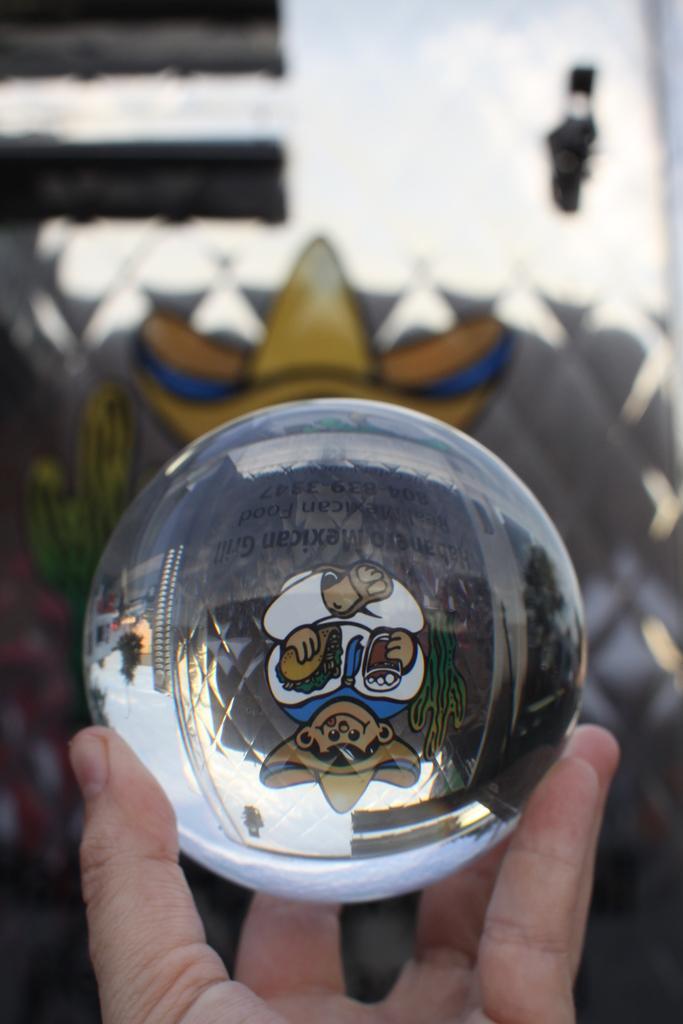How would you summarize this image in a sentence or two? In this image we can see a round object in the hand of a person, there are text and image on the object, there is a reflection of a building on it, also the background is blurred. 